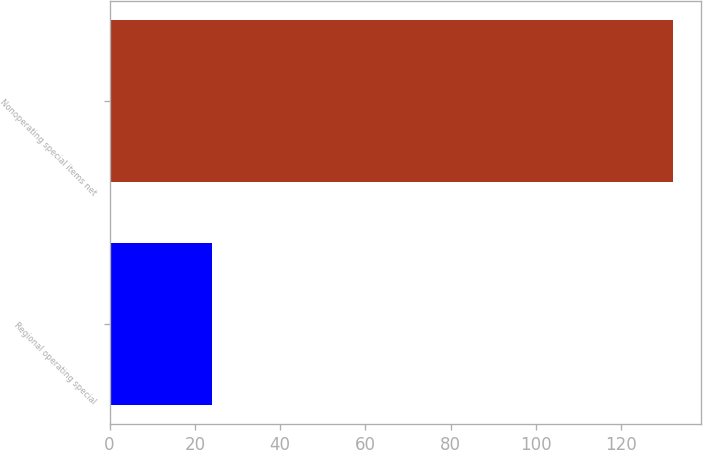Convert chart to OTSL. <chart><loc_0><loc_0><loc_500><loc_500><bar_chart><fcel>Regional operating special<fcel>Nonoperating special items net<nl><fcel>24<fcel>132<nl></chart> 